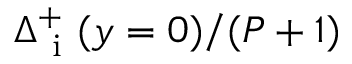<formula> <loc_0><loc_0><loc_500><loc_500>\Delta _ { i } ^ { + } ( y = 0 ) / ( P + 1 )</formula> 